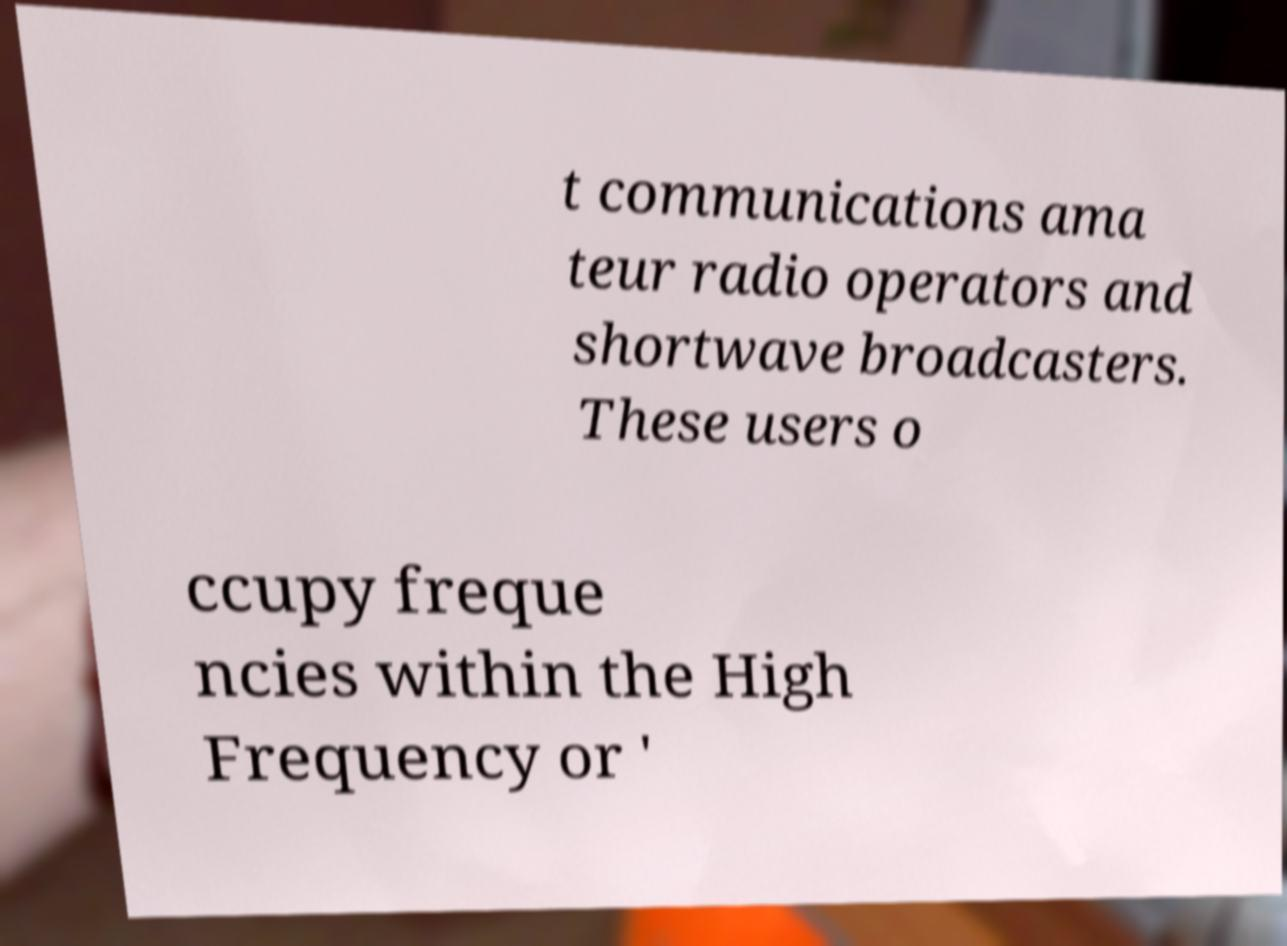Could you extract and type out the text from this image? t communications ama teur radio operators and shortwave broadcasters. These users o ccupy freque ncies within the High Frequency or ' 